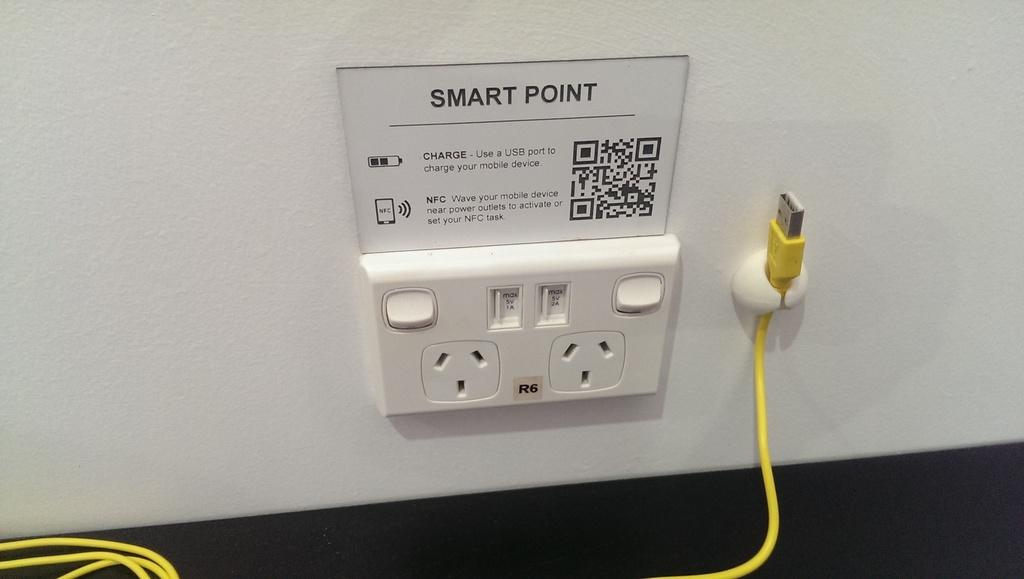What is on the wall in the image? There is a switch board on the board on the wall in the image. What is located near the switch board? There is a yellow charger wire beside the switch board. What can be seen on the switch board itself? There are notes on the switch board. What type of yarn is being used to tie the beef in the image? There is no yarn or beef present in the image; it features a switch board with a yellow charger wire and notes. 